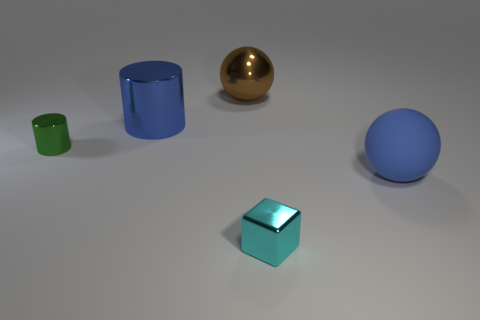Is the number of blue rubber balls greater than the number of small things?
Provide a succinct answer. No. What material is the tiny cyan object?
Your response must be concise. Metal. What number of big blue things are right of the big shiny object that is to the right of the big blue metal object?
Provide a short and direct response. 1. There is a big cylinder; is its color the same as the small block that is in front of the blue cylinder?
Give a very brief answer. No. The other ball that is the same size as the blue rubber sphere is what color?
Keep it short and to the point. Brown. Is there a green shiny thing that has the same shape as the large blue rubber object?
Your answer should be very brief. No. Is the number of blue metal cylinders less than the number of large blue objects?
Provide a short and direct response. Yes. There is a small object on the right side of the blue metal thing; what color is it?
Provide a short and direct response. Cyan. There is a large blue thing that is left of the big ball left of the tiny cyan object; what shape is it?
Provide a succinct answer. Cylinder. Is the large brown object made of the same material as the blue object behind the blue rubber sphere?
Provide a short and direct response. Yes. 